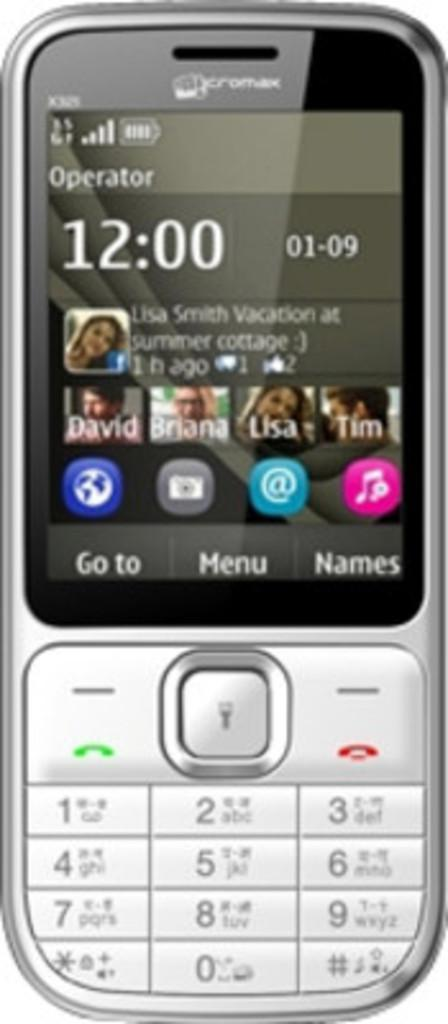<image>
Create a compact narrative representing the image presented. an old cellphone has the numbers x325 written in the upper left hand corner 